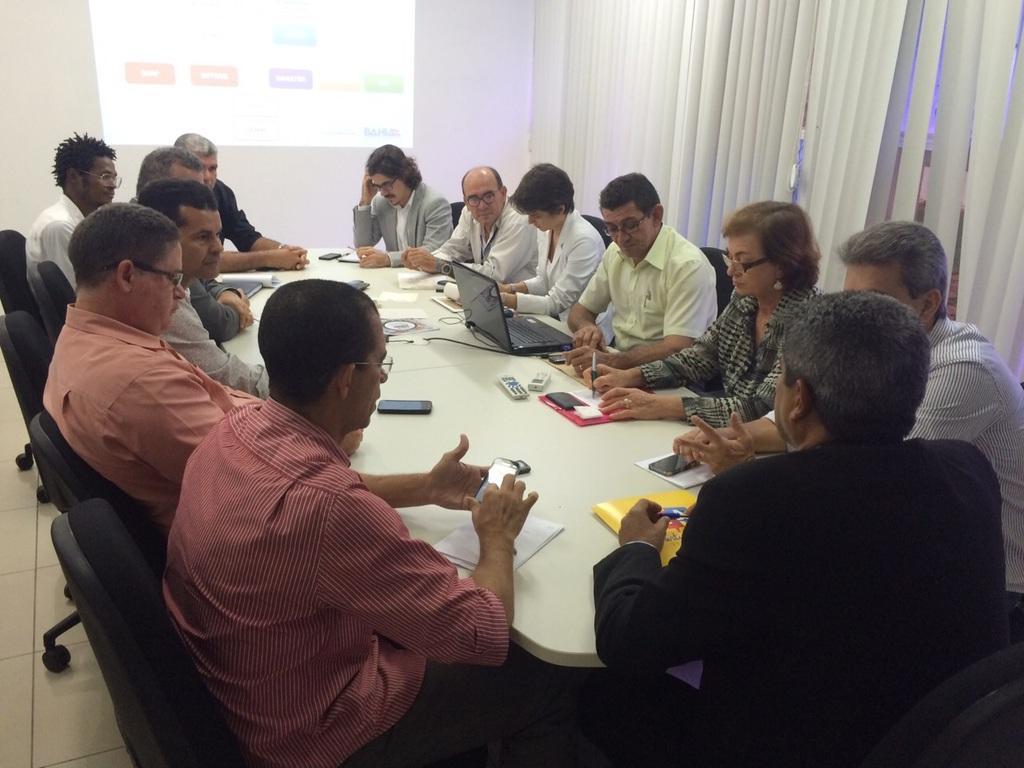Can you describe this image briefly? There are group of people sitting on the chairs. This is a table with a laptop,mobile phones,papers,books,remotes and some other things on it. This looks like a screen. These are the curtains. 